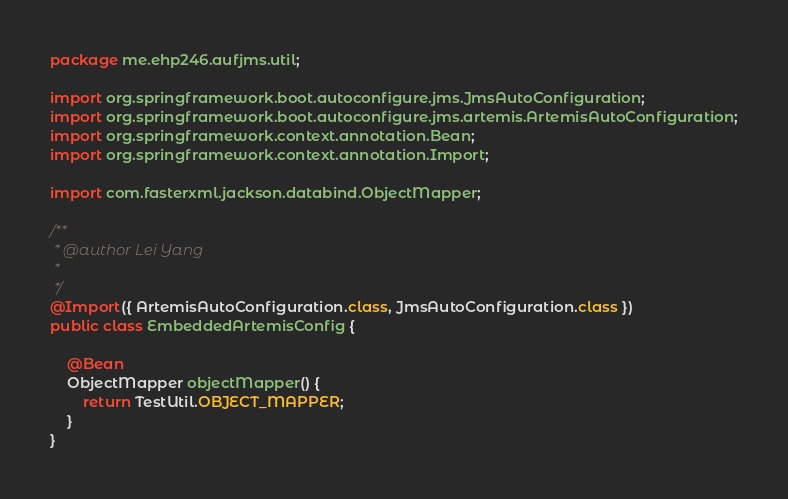<code> <loc_0><loc_0><loc_500><loc_500><_Java_>package me.ehp246.aufjms.util;

import org.springframework.boot.autoconfigure.jms.JmsAutoConfiguration;
import org.springframework.boot.autoconfigure.jms.artemis.ArtemisAutoConfiguration;
import org.springframework.context.annotation.Bean;
import org.springframework.context.annotation.Import;

import com.fasterxml.jackson.databind.ObjectMapper;

/**
 * @author Lei Yang
 *
 */
@Import({ ArtemisAutoConfiguration.class, JmsAutoConfiguration.class })
public class EmbeddedArtemisConfig {

    @Bean
    ObjectMapper objectMapper() {
        return TestUtil.OBJECT_MAPPER;
    }
}
</code> 